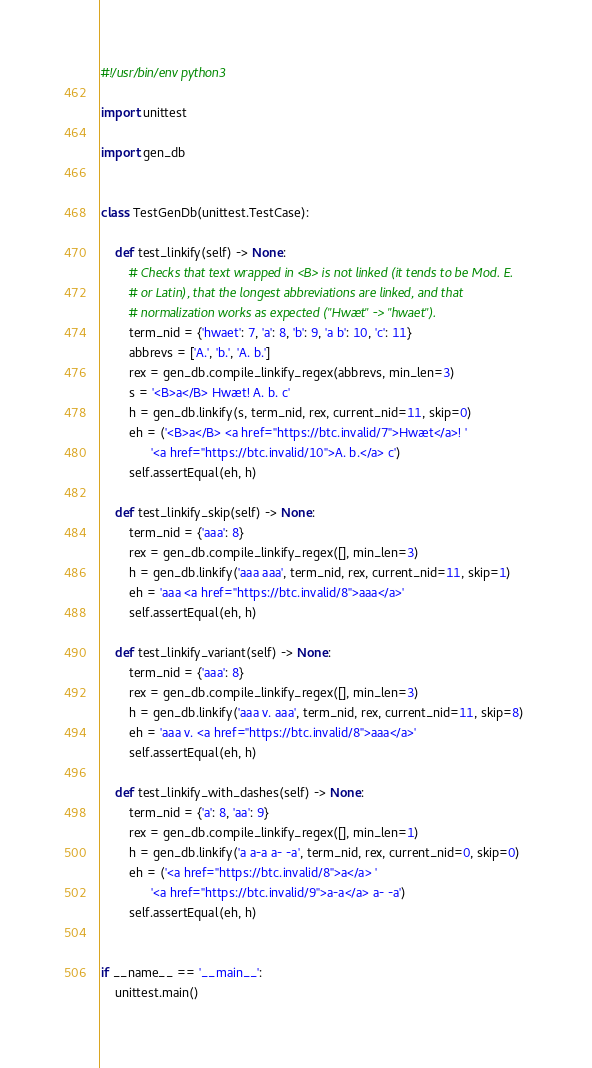Convert code to text. <code><loc_0><loc_0><loc_500><loc_500><_Python_>#!/usr/bin/env python3

import unittest

import gen_db


class TestGenDb(unittest.TestCase):

    def test_linkify(self) -> None:
        # Checks that text wrapped in <B> is not linked (it tends to be Mod. E.
        # or Latin), that the longest abbreviations are linked, and that
        # normalization works as expected ("Hwæt" -> "hwaet").
        term_nid = {'hwaet': 7, 'a': 8, 'b': 9, 'a b': 10, 'c': 11}
        abbrevs = ['A.', 'b.', 'A. b.']
        rex = gen_db.compile_linkify_regex(abbrevs, min_len=3)
        s = '<B>a</B> Hwæt! A. b. c'
        h = gen_db.linkify(s, term_nid, rex, current_nid=11, skip=0)
        eh = ('<B>a</B> <a href="https://btc.invalid/7">Hwæt</a>! '
              '<a href="https://btc.invalid/10">A. b.</a> c')
        self.assertEqual(eh, h)

    def test_linkify_skip(self) -> None:
        term_nid = {'aaa': 8}
        rex = gen_db.compile_linkify_regex([], min_len=3)
        h = gen_db.linkify('aaa aaa', term_nid, rex, current_nid=11, skip=1)
        eh = 'aaa <a href="https://btc.invalid/8">aaa</a>'
        self.assertEqual(eh, h)

    def test_linkify_variant(self) -> None:
        term_nid = {'aaa': 8}
        rex = gen_db.compile_linkify_regex([], min_len=3)
        h = gen_db.linkify('aaa v. aaa', term_nid, rex, current_nid=11, skip=8)
        eh = 'aaa v. <a href="https://btc.invalid/8">aaa</a>'
        self.assertEqual(eh, h)

    def test_linkify_with_dashes(self) -> None:
        term_nid = {'a': 8, 'aa': 9}
        rex = gen_db.compile_linkify_regex([], min_len=1)
        h = gen_db.linkify('a a-a a- -a', term_nid, rex, current_nid=0, skip=0)
        eh = ('<a href="https://btc.invalid/8">a</a> '
              '<a href="https://btc.invalid/9">a-a</a> a- -a')
        self.assertEqual(eh, h)


if __name__ == '__main__':
    unittest.main()
</code> 